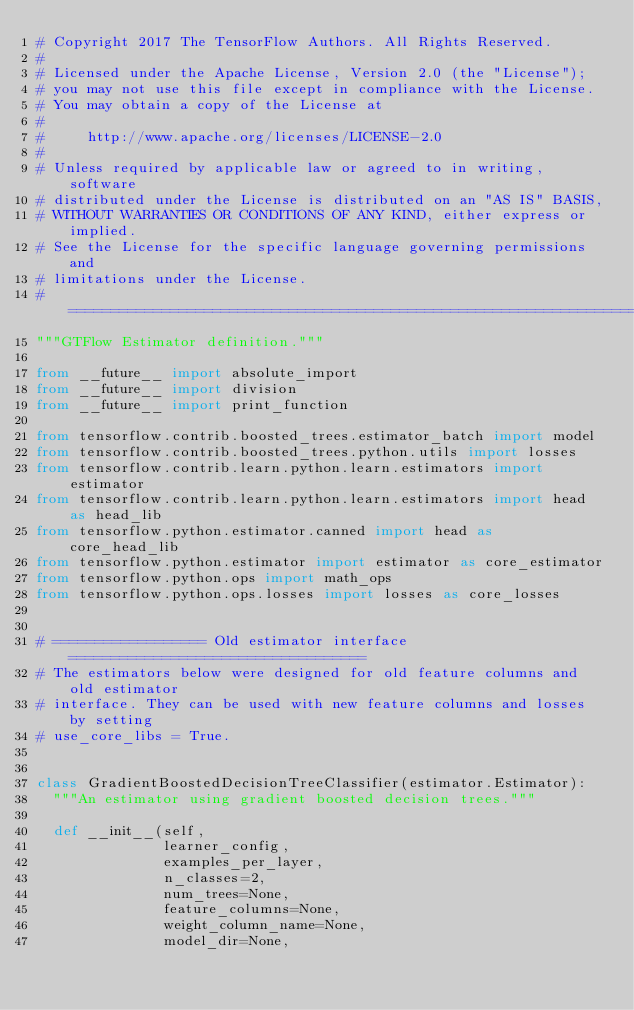Convert code to text. <code><loc_0><loc_0><loc_500><loc_500><_Python_># Copyright 2017 The TensorFlow Authors. All Rights Reserved.
#
# Licensed under the Apache License, Version 2.0 (the "License");
# you may not use this file except in compliance with the License.
# You may obtain a copy of the License at
#
#     http://www.apache.org/licenses/LICENSE-2.0
#
# Unless required by applicable law or agreed to in writing, software
# distributed under the License is distributed on an "AS IS" BASIS,
# WITHOUT WARRANTIES OR CONDITIONS OF ANY KIND, either express or implied.
# See the License for the specific language governing permissions and
# limitations under the License.
# ==============================================================================
"""GTFlow Estimator definition."""

from __future__ import absolute_import
from __future__ import division
from __future__ import print_function

from tensorflow.contrib.boosted_trees.estimator_batch import model
from tensorflow.contrib.boosted_trees.python.utils import losses
from tensorflow.contrib.learn.python.learn.estimators import estimator
from tensorflow.contrib.learn.python.learn.estimators import head as head_lib
from tensorflow.python.estimator.canned import head as core_head_lib
from tensorflow.python.estimator import estimator as core_estimator
from tensorflow.python.ops import math_ops
from tensorflow.python.ops.losses import losses as core_losses


# ================== Old estimator interface===================================
# The estimators below were designed for old feature columns and old estimator
# interface. They can be used with new feature columns and losses by setting
# use_core_libs = True.


class GradientBoostedDecisionTreeClassifier(estimator.Estimator):
  """An estimator using gradient boosted decision trees."""

  def __init__(self,
               learner_config,
               examples_per_layer,
               n_classes=2,
               num_trees=None,
               feature_columns=None,
               weight_column_name=None,
               model_dir=None,</code> 